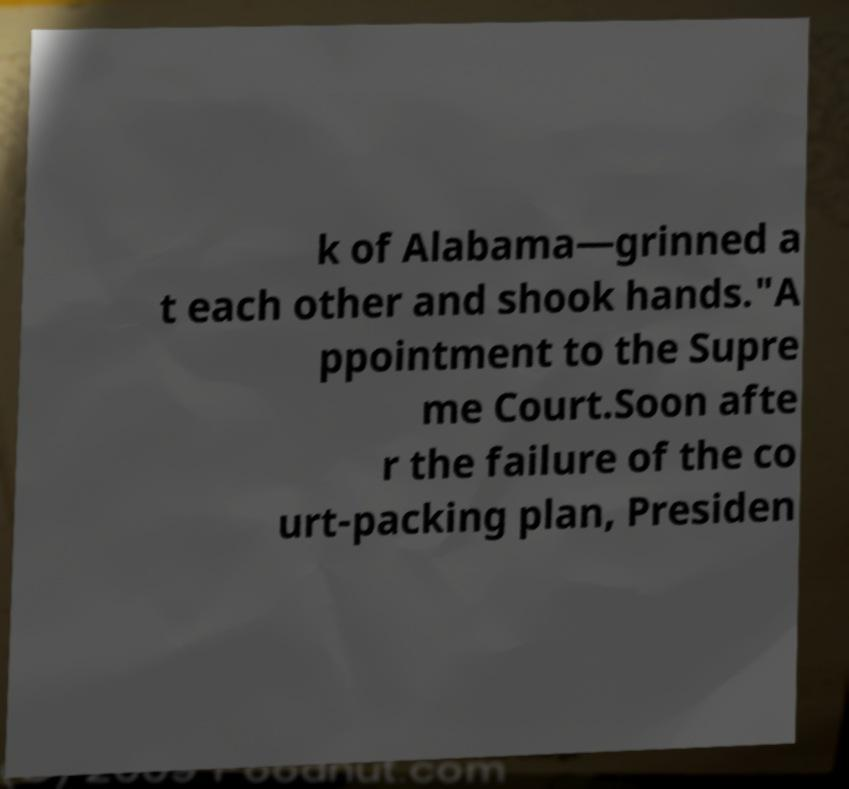Please read and relay the text visible in this image. What does it say? k of Alabama—grinned a t each other and shook hands."A ppointment to the Supre me Court.Soon afte r the failure of the co urt-packing plan, Presiden 